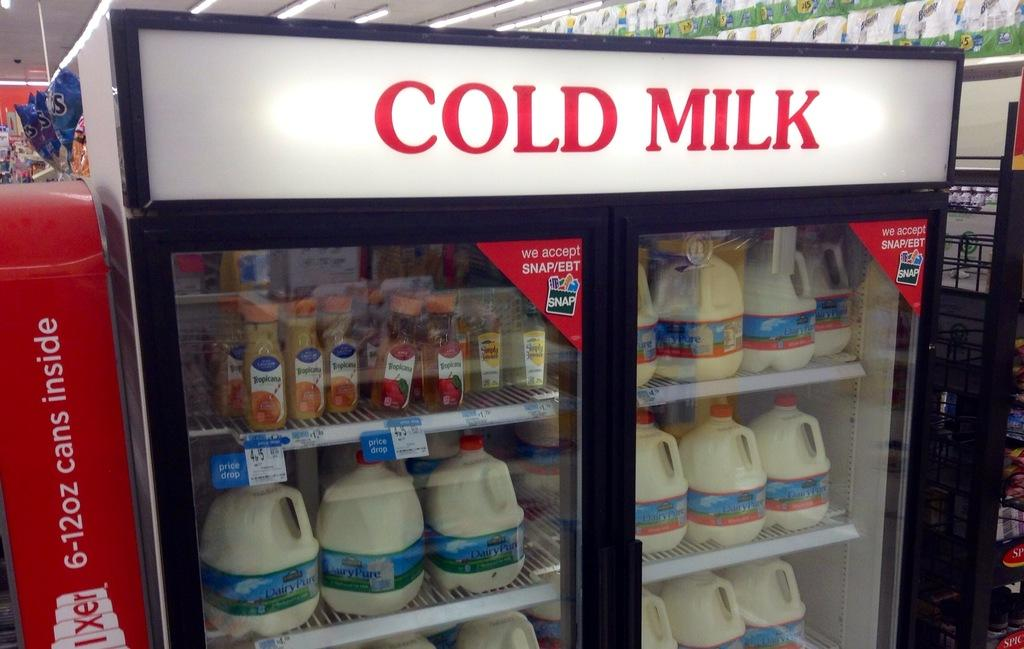<image>
Provide a brief description of the given image. a store refrigerator that says 'cold milk' in red on top 